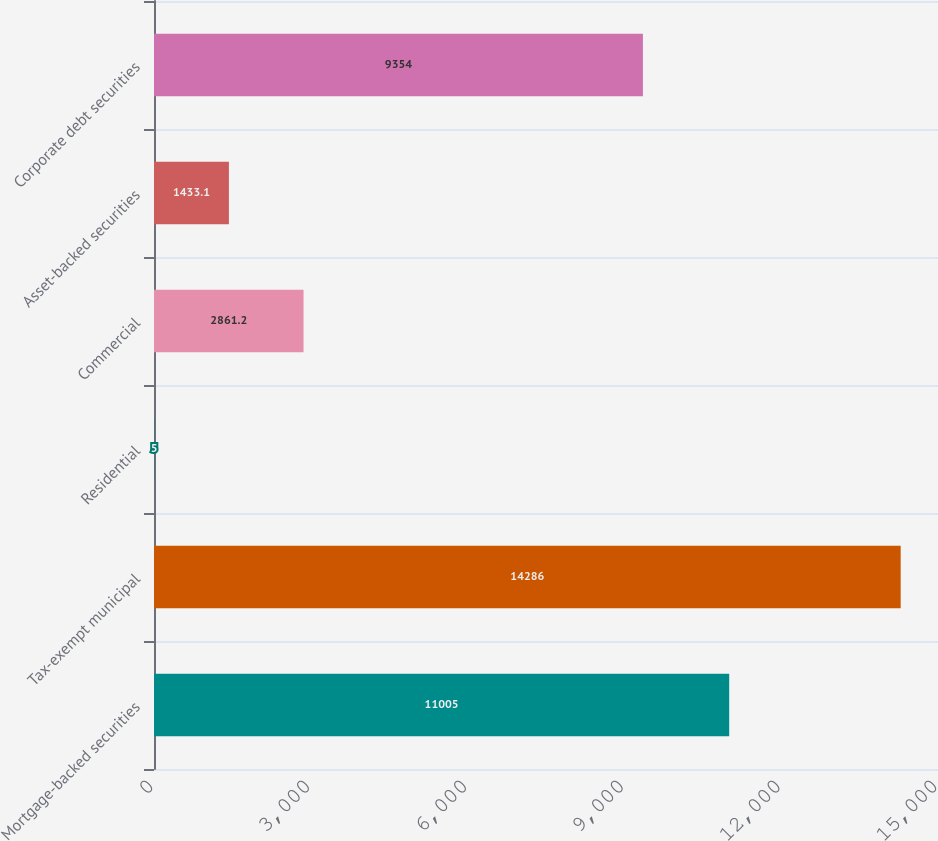Convert chart to OTSL. <chart><loc_0><loc_0><loc_500><loc_500><bar_chart><fcel>Mortgage-backed securities<fcel>Tax-exempt municipal<fcel>Residential<fcel>Commercial<fcel>Asset-backed securities<fcel>Corporate debt securities<nl><fcel>11005<fcel>14286<fcel>5<fcel>2861.2<fcel>1433.1<fcel>9354<nl></chart> 